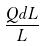Convert formula to latex. <formula><loc_0><loc_0><loc_500><loc_500>\frac { Q d L } { L }</formula> 